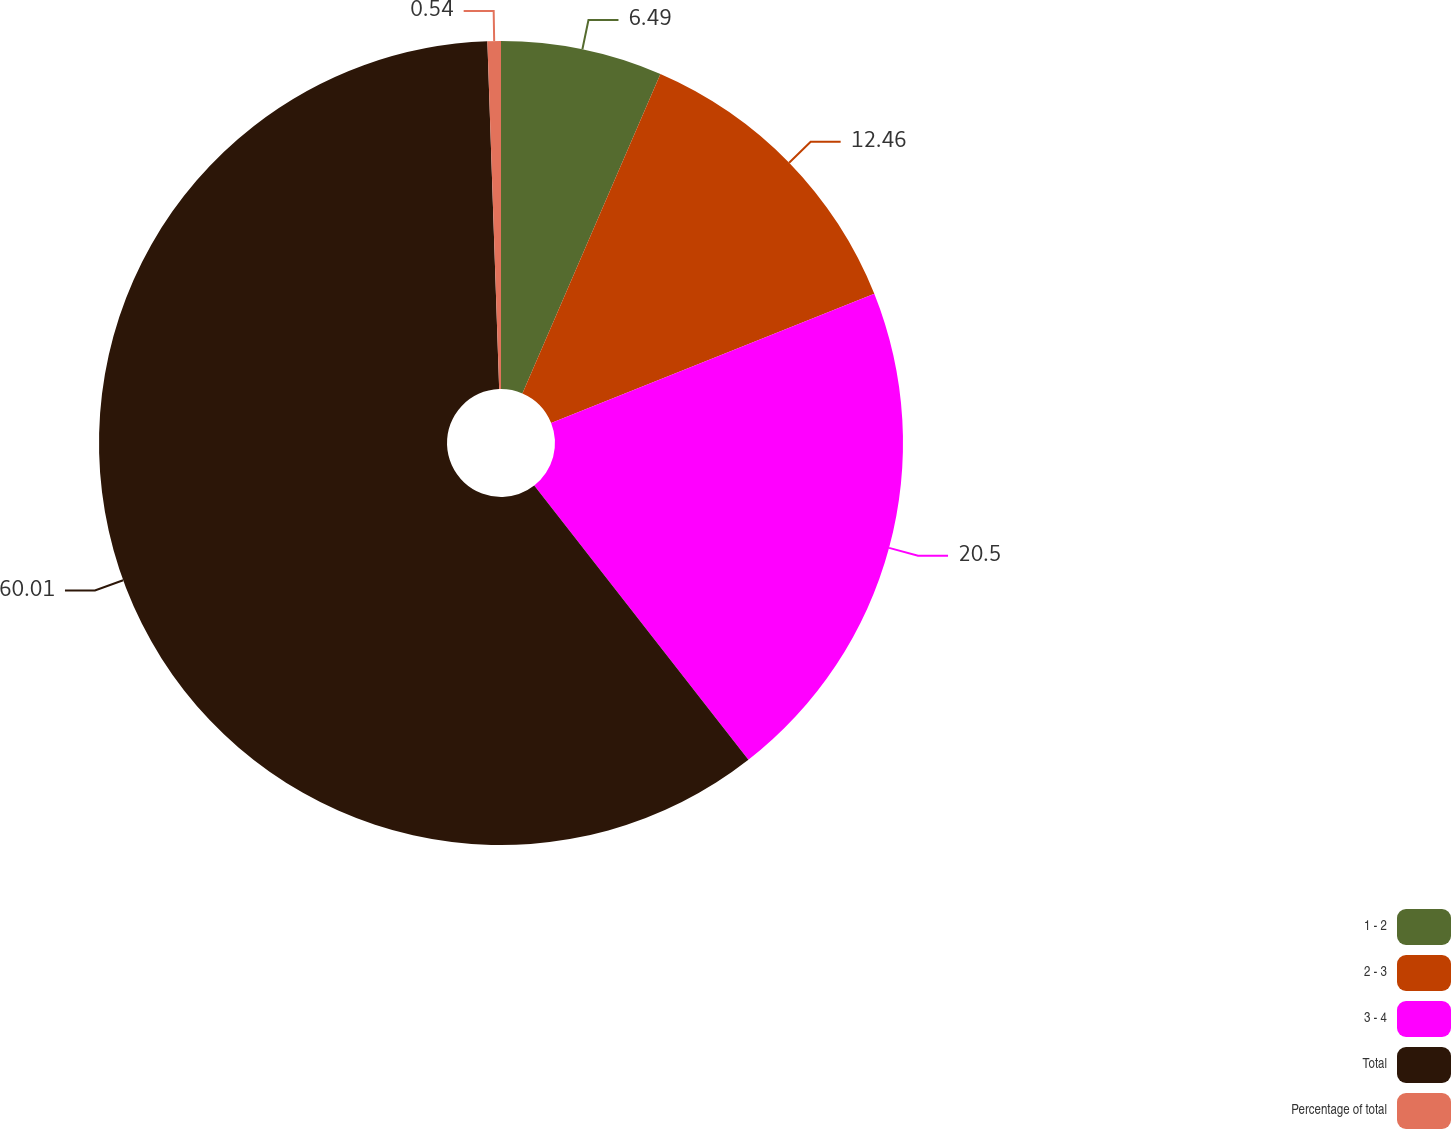<chart> <loc_0><loc_0><loc_500><loc_500><pie_chart><fcel>1 - 2<fcel>2 - 3<fcel>3 - 4<fcel>Total<fcel>Percentage of total<nl><fcel>6.49%<fcel>12.46%<fcel>20.5%<fcel>60.01%<fcel>0.54%<nl></chart> 